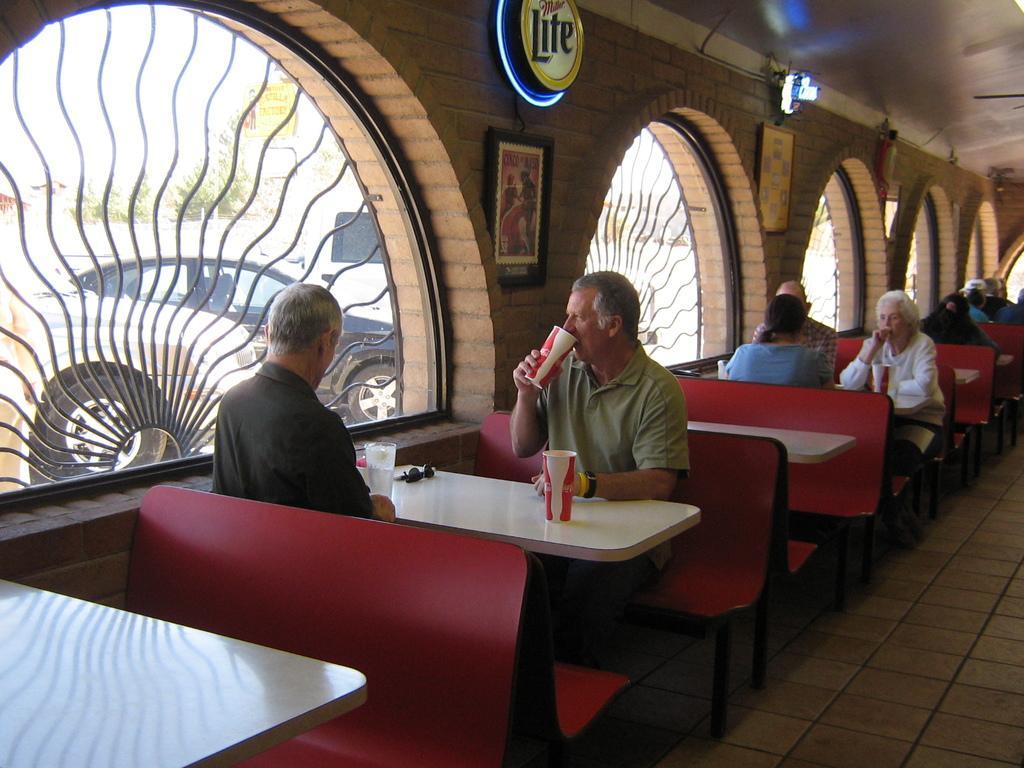Could you give a brief overview of what you see in this image? In this image we can see few persons. The persons are sitting on benches. There are few objects on the tables. Beside the person we can see a wall. On the wall we can see frames and glasses. Through the glass in the foreground we can see vehicles, trees and the sky. At the top we can see the roof and a board with text. 